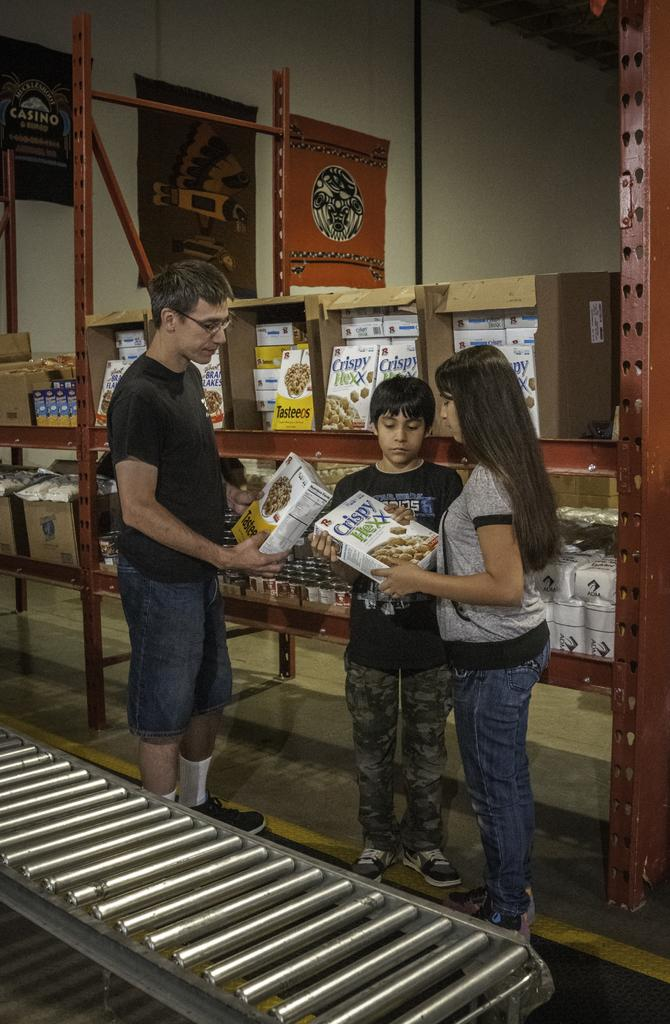What is happening in the image? There are people standing in the image. What can be seen in the background of the image? There are boxes in the background of the image. What is the wall visible in the image made of? The wall visible in the image is made of a material that cannot be determined from the image alone. How many steps does the border take to reach the other side in the image? There is no border present in the image, so it is not possible to determine the number of steps it would take to reach the other side. 